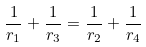<formula> <loc_0><loc_0><loc_500><loc_500>\frac { 1 } { r _ { 1 } } + \frac { 1 } { r _ { 3 } } = \frac { 1 } { r _ { 2 } } + \frac { 1 } { r _ { 4 } }</formula> 